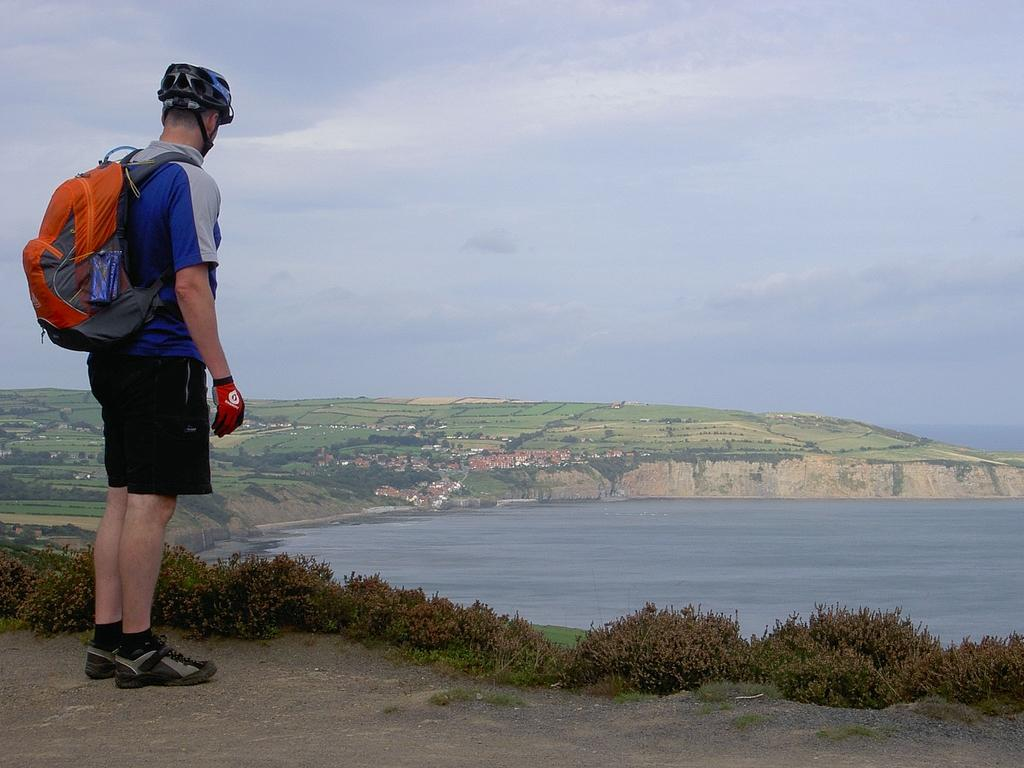What is the man doing on the left side of the image? The man is standing on the left side of the image. What is the man carrying on his back? The man is wearing a backpack. What can be seen in the background of the image? There is a river, a hill, and the sky visible in the background of the image. What type of vegetation is present at the bottom of the image? There are shrubs at the bottom of the image. What type of songs can be heard coming from the horses in the image? There are no horses present in the image, so it's not possible to determine what, if any, songs might be heard. 